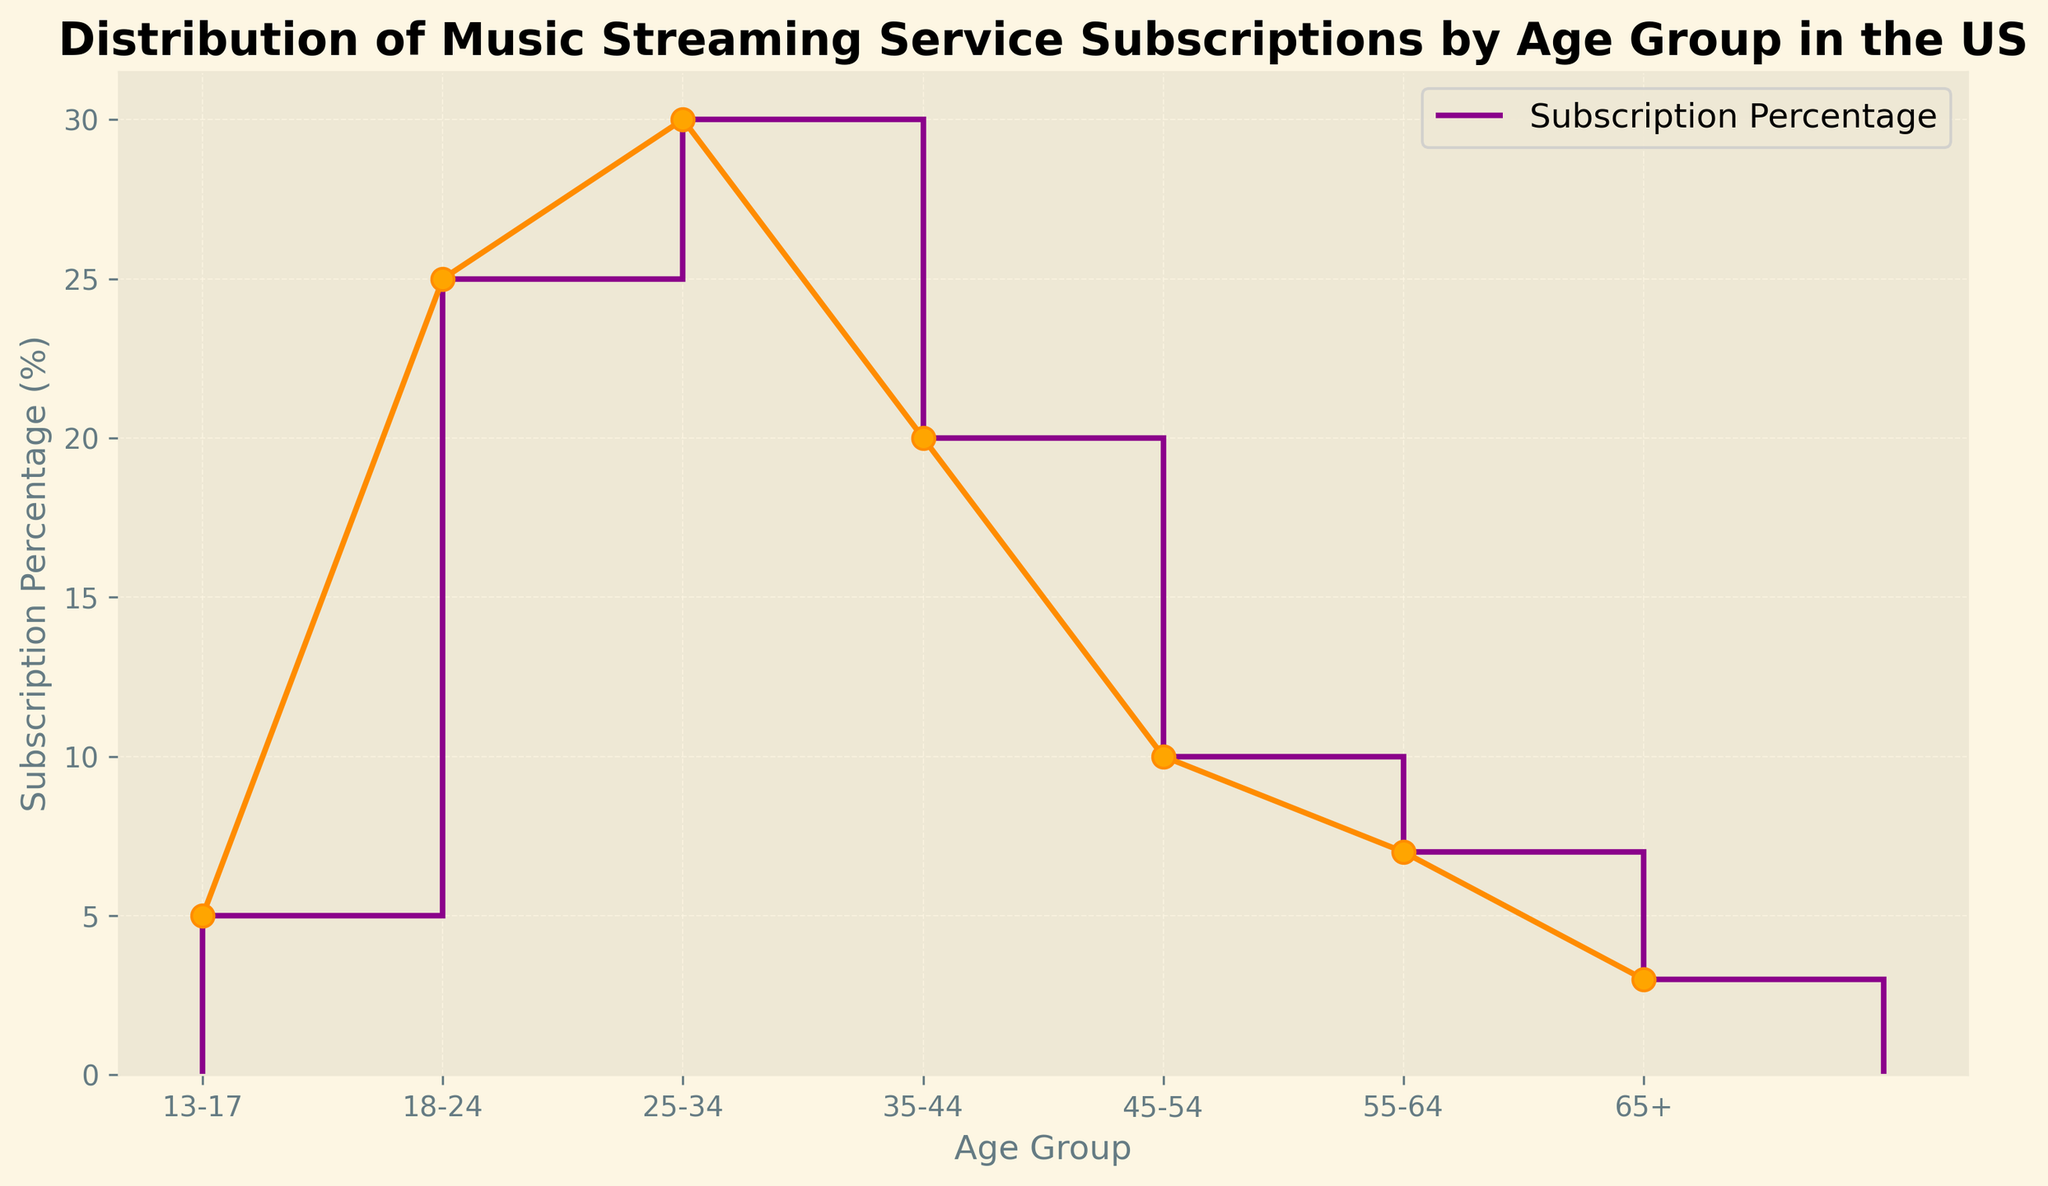Which age group has the highest subscription percentage? The age group with the highest subscription percentage can be identified by looking at the highest point in the stairs plot. The age group 25-34 has the highest value.
Answer: 25-34 What is the difference in subscription percentage between the 18-24 and 45-54 age groups? To find the difference between the subscription percentages of the two age groups, subtract the percentage of the 45-54 group from the percentage of the 18-24 group. That is, 25% (18-24) - 10% (45-54).
Answer: 15% What is the average subscription percentage of age groups 35-44, 45-54, and 55-64? To find the average, add the percentages of these age groups and divide by the number of groups: (20% + 10% + 7%) / 3 = 37% / 3.
Answer: 12.3% Which age group has a subscription percentage closest to the median value of the dataset? Calculate the median of the percentages (3%, 5%, 7%, 10%, 20%, 25%, 30%) which is 10%. The age group 45-54 has a percentage closest to this median value.
Answer: 45-54 How much higher is the subscription percentage of the 25-34 group compared to the 65+ group? Subtract the subscription percentage of the 65+ group from the 25-34 group: 30% - 3%.
Answer: 27% What is the total subscription percentage of all age groups combined? Simply sum all the subscription percentages: 5% + 25% + 30% + 20% + 10% + 7% + 3% = 100%.
Answer: 100% Which age group shows a higher subscription percentage: 35-44 or 13-17? Compare the subscription percentages of these two age groups. 20% (35-44) is higher than 5% (13-17).
Answer: 35-44 What percentage range do the majority of the age groups fall into? Observe the visual plot and identify the range with most age groups' percentages. Group 18-24 to 45-54 fall between 10% and 30%.
Answer: 10%-30% Between which two age groups is the largest drop in subscription percentage observed? Identify where the most significant drop occurs by visual inspection of the plot. The largest drop is between the 25-34 (30%) and 35-44 (20%) groups.
Answer: 25-34 and 35-44 What is the combined subscription percentage of the age groups below 25? Sum the subscription percentages of the age groups 13-17 and 18-24: 5% + 25%.
Answer: 30% 